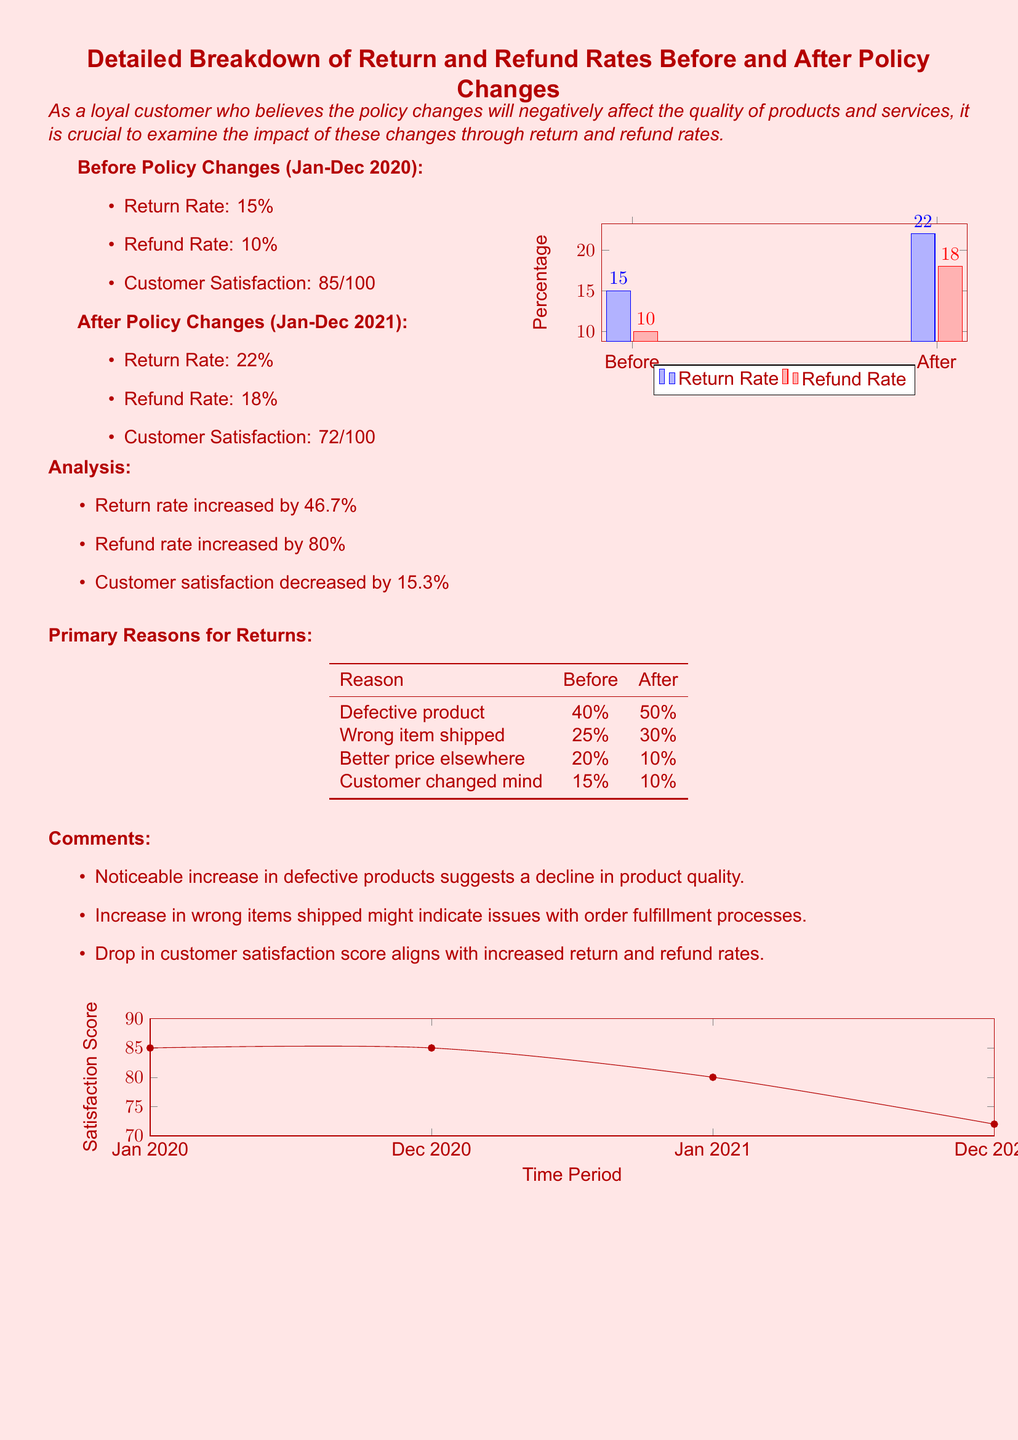What was the return rate before policy changes? The return rate before policy changes is stated as 15%.
Answer: 15% What was the refund rate after policy changes? The refund rate after policy changes is listed as 18%.
Answer: 18% By how much did the return rate increase after the policy changes? The return rate increased from 15% to 22%, which is a 46.7% increase.
Answer: 46.7% What was the customer satisfaction score before the policy changes? The customer satisfaction score before the policy changes was 85 out of 100.
Answer: 85/100 What percentage of returns were due to defective products after policy changes? The document notes that 50% of returns were due to defective products after the policy changes.
Answer: 50% What trend is indicated by the graph showing satisfaction scores over time? The graph shows a decline in customer satisfaction scores over time.
Answer: Decline What is the primary reason for returns that decreased after policy changes? The primary reason that decreased is "Better price elsewhere," from 20% to 10%.
Answer: Better price elsewhere What overall impact do the policy changes appear to have on customer satisfaction? The overall impact appears to be negative, with a decrease in customer satisfaction scores.
Answer: Negative What two rates increased as a result of the policy changes? The two rates that increased are return rate and refund rate.
Answer: Return rate and refund rate 